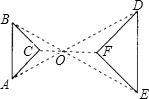Elaborate on what is shown in the illustration. The illustration presents two similar triangles, ABC and DEF, with corresponding vertices labeled accordingly. Besides noting that side AB of triangle ABC measures 4.0 units, it is important to observe that both triangles appear to share the same center point 'O', which suggests they may be concentric. The dashed lines connecting corresponding vertices imply that the two triangles are not only similar in shape but also proportionally scaled. Details like the angles at which the triangles intersect, the lengths of other sides, and any specific properties or theorems being demonstrated are not provided in this image, yet they could be key to fully grasping this geometrical concept. 